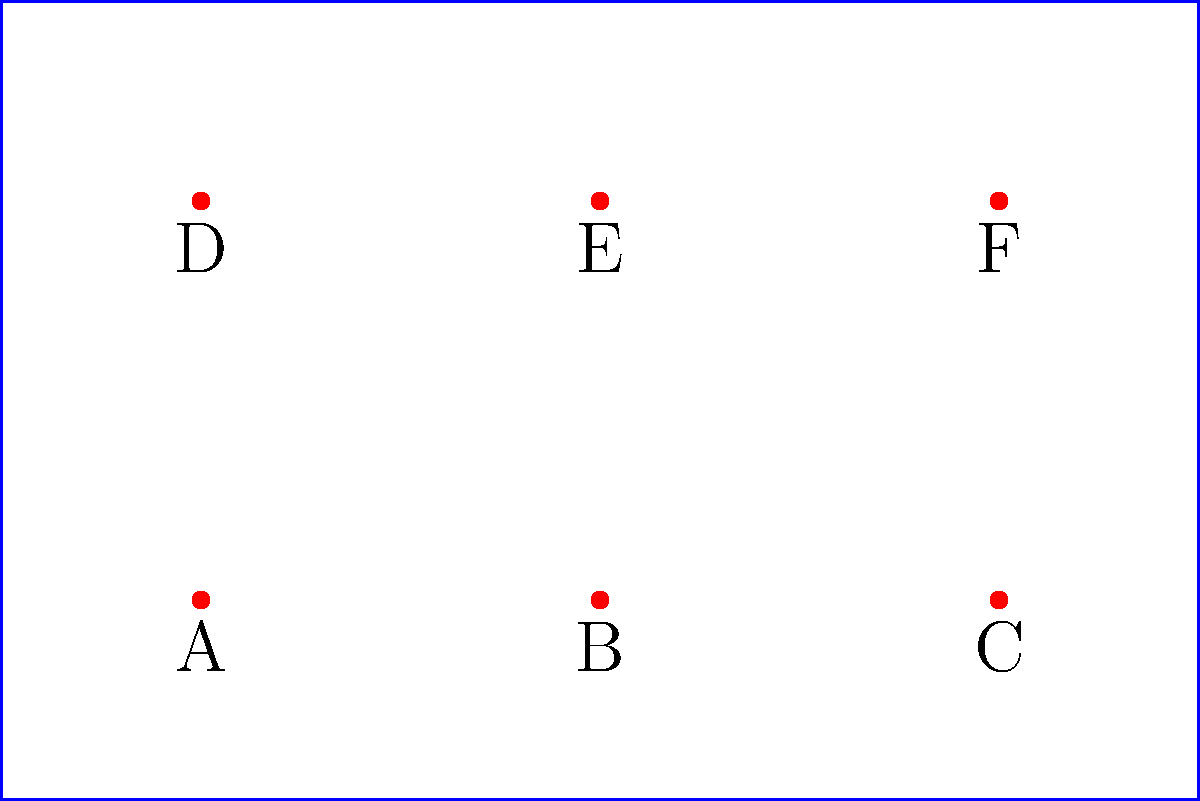In a museum gallery, there are 6 exhibit spaces labeled A, B, C, D, E, and F, arranged in a 2x3 grid as shown in the diagram. How many unique ways can you arrange 6 different exhibits in these spaces, assuming rotations and reflections of the entire arrangement are considered distinct? Let's approach this step-by-step:

1) First, we need to understand what the question is asking. We're dealing with permutations of 6 distinct objects (the exhibits) in 6 distinct positions.

2) In general, the number of ways to arrange n distinct objects in n positions is given by n!.

3) In this case, we have 6 exhibits and 6 positions, so the number of permutations would be 6!.

4) Let's calculate 6!:
   $$6! = 6 \times 5 \times 4 \times 3 \times 2 \times 1 = 720$$

5) The question specifically states that rotations and reflections of the entire arrangement are considered distinct. This means we don't need to account for any symmetries in the arrangement.

6) Therefore, the total number of unique arrangements is indeed 720.

This problem relates to the symmetric group $S_6$, which is the group of all permutations on 6 elements. The order of this group is 6!, which matches our answer.
Answer: 720 